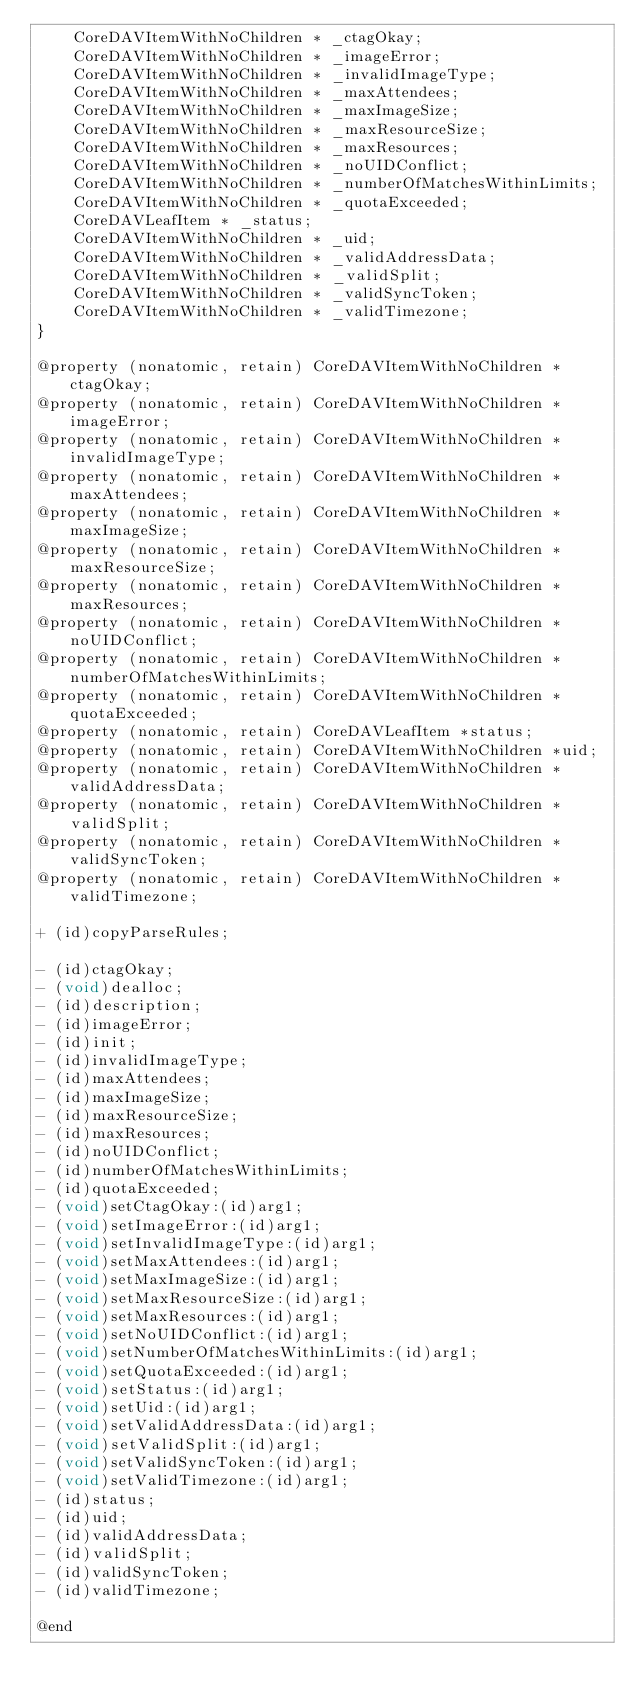<code> <loc_0><loc_0><loc_500><loc_500><_C_>    CoreDAVItemWithNoChildren * _ctagOkay;
    CoreDAVItemWithNoChildren * _imageError;
    CoreDAVItemWithNoChildren * _invalidImageType;
    CoreDAVItemWithNoChildren * _maxAttendees;
    CoreDAVItemWithNoChildren * _maxImageSize;
    CoreDAVItemWithNoChildren * _maxResourceSize;
    CoreDAVItemWithNoChildren * _maxResources;
    CoreDAVItemWithNoChildren * _noUIDConflict;
    CoreDAVItemWithNoChildren * _numberOfMatchesWithinLimits;
    CoreDAVItemWithNoChildren * _quotaExceeded;
    CoreDAVLeafItem * _status;
    CoreDAVItemWithNoChildren * _uid;
    CoreDAVItemWithNoChildren * _validAddressData;
    CoreDAVItemWithNoChildren * _validSplit;
    CoreDAVItemWithNoChildren * _validSyncToken;
    CoreDAVItemWithNoChildren * _validTimezone;
}

@property (nonatomic, retain) CoreDAVItemWithNoChildren *ctagOkay;
@property (nonatomic, retain) CoreDAVItemWithNoChildren *imageError;
@property (nonatomic, retain) CoreDAVItemWithNoChildren *invalidImageType;
@property (nonatomic, retain) CoreDAVItemWithNoChildren *maxAttendees;
@property (nonatomic, retain) CoreDAVItemWithNoChildren *maxImageSize;
@property (nonatomic, retain) CoreDAVItemWithNoChildren *maxResourceSize;
@property (nonatomic, retain) CoreDAVItemWithNoChildren *maxResources;
@property (nonatomic, retain) CoreDAVItemWithNoChildren *noUIDConflict;
@property (nonatomic, retain) CoreDAVItemWithNoChildren *numberOfMatchesWithinLimits;
@property (nonatomic, retain) CoreDAVItemWithNoChildren *quotaExceeded;
@property (nonatomic, retain) CoreDAVLeafItem *status;
@property (nonatomic, retain) CoreDAVItemWithNoChildren *uid;
@property (nonatomic, retain) CoreDAVItemWithNoChildren *validAddressData;
@property (nonatomic, retain) CoreDAVItemWithNoChildren *validSplit;
@property (nonatomic, retain) CoreDAVItemWithNoChildren *validSyncToken;
@property (nonatomic, retain) CoreDAVItemWithNoChildren *validTimezone;

+ (id)copyParseRules;

- (id)ctagOkay;
- (void)dealloc;
- (id)description;
- (id)imageError;
- (id)init;
- (id)invalidImageType;
- (id)maxAttendees;
- (id)maxImageSize;
- (id)maxResourceSize;
- (id)maxResources;
- (id)noUIDConflict;
- (id)numberOfMatchesWithinLimits;
- (id)quotaExceeded;
- (void)setCtagOkay:(id)arg1;
- (void)setImageError:(id)arg1;
- (void)setInvalidImageType:(id)arg1;
- (void)setMaxAttendees:(id)arg1;
- (void)setMaxImageSize:(id)arg1;
- (void)setMaxResourceSize:(id)arg1;
- (void)setMaxResources:(id)arg1;
- (void)setNoUIDConflict:(id)arg1;
- (void)setNumberOfMatchesWithinLimits:(id)arg1;
- (void)setQuotaExceeded:(id)arg1;
- (void)setStatus:(id)arg1;
- (void)setUid:(id)arg1;
- (void)setValidAddressData:(id)arg1;
- (void)setValidSplit:(id)arg1;
- (void)setValidSyncToken:(id)arg1;
- (void)setValidTimezone:(id)arg1;
- (id)status;
- (id)uid;
- (id)validAddressData;
- (id)validSplit;
- (id)validSyncToken;
- (id)validTimezone;

@end
</code> 